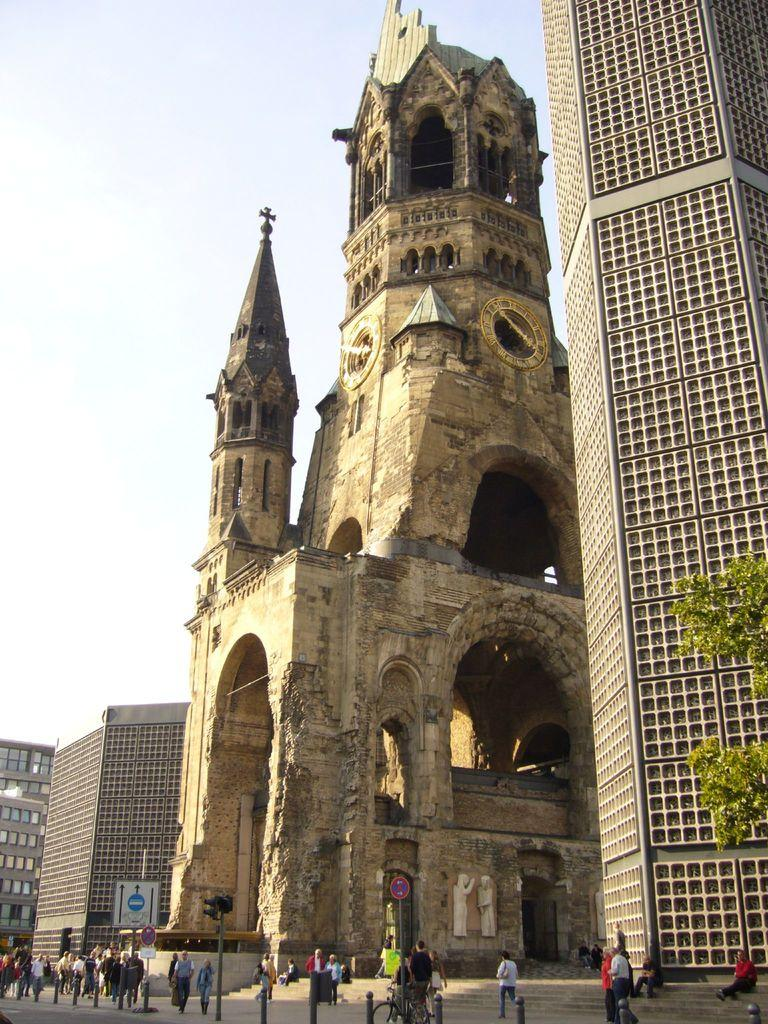What type of structures can be seen in the image? There are buildings in the image. What other natural elements are present in the image? There are trees in the image. What are the people in the image doing? There are persons standing on the road and sitting on stairs in the image. What objects can be seen that provide information or directions? There are sign boards in the image. What type of material is used for the poles in the image? There are metal poles in the image. What can be seen on the ground in the image? The road is visible in the image. What part of the natural environment is visible in the image? The sky is visible in the image. What type of flesh can be seen on the persons sitting on the stairs in the image? There is no mention of flesh or any specific body parts in the image; it only shows persons sitting on stairs. What type of pleasure can be experienced by the persons standing on the road in the image? The image does not provide any information about the emotions or experiences of the persons in the image, so it cannot be determined what type of pleasure they might be experiencing. 